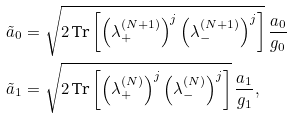<formula> <loc_0><loc_0><loc_500><loc_500>\tilde { a } _ { 0 } & = \sqrt { 2 \, \text {Tr} \left [ \left ( \lambda ^ { ( N + 1 ) } _ { + } \right ) ^ { j } \left ( \lambda ^ { ( N + 1 ) } _ { - } \right ) ^ { j } \right ] } \, \frac { a _ { 0 } } { g _ { 0 } } \\ \tilde { a } _ { 1 } & = \sqrt { 2 \, \text {Tr} \left [ \left ( \lambda ^ { ( N ) } _ { + } \right ) ^ { j } \left ( \lambda ^ { ( N ) } _ { - } \right ) ^ { j } \right ] } \, \frac { a _ { 1 } } { g _ { 1 } } ,</formula> 